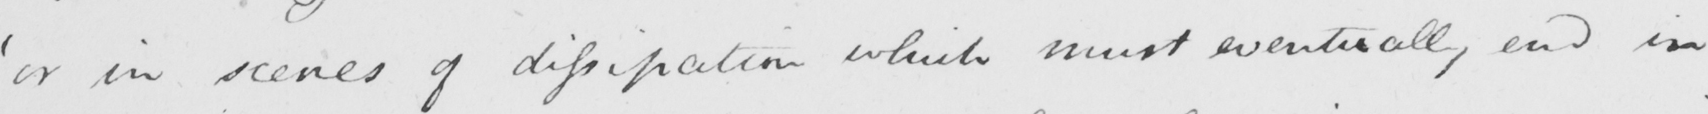Please transcribe the handwritten text in this image. ' or in scenes of dissipation which must eventually end in 